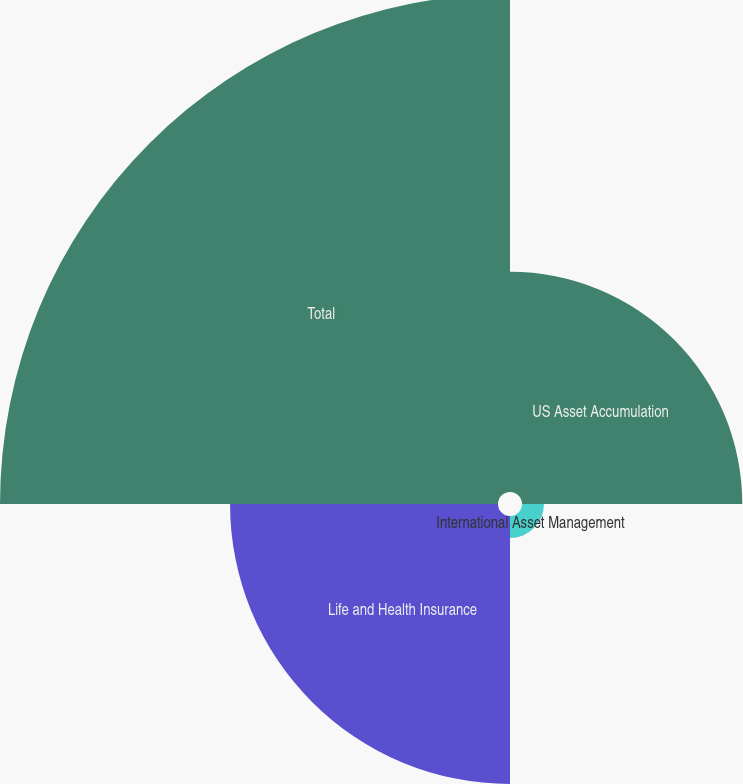Convert chart. <chart><loc_0><loc_0><loc_500><loc_500><pie_chart><fcel>US Asset Accumulation<fcel>International Asset Management<fcel>Life and Health Insurance<fcel>Total<nl><fcel>21.85%<fcel>2.18%<fcel>26.58%<fcel>49.4%<nl></chart> 